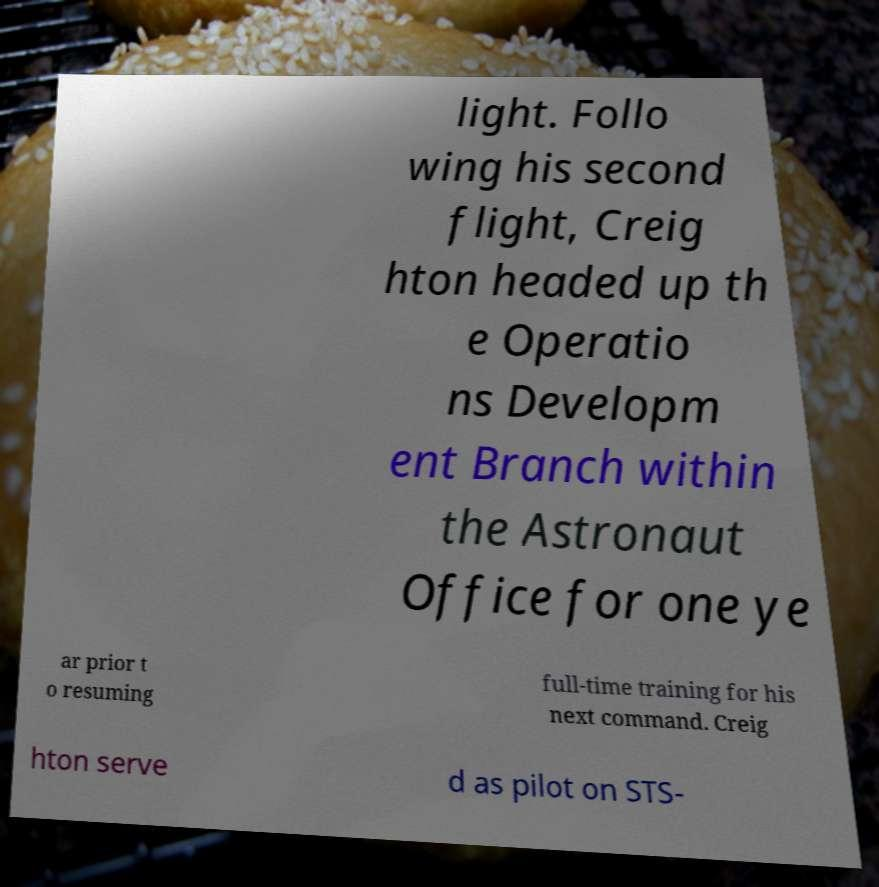There's text embedded in this image that I need extracted. Can you transcribe it verbatim? light. Follo wing his second flight, Creig hton headed up th e Operatio ns Developm ent Branch within the Astronaut Office for one ye ar prior t o resuming full-time training for his next command. Creig hton serve d as pilot on STS- 